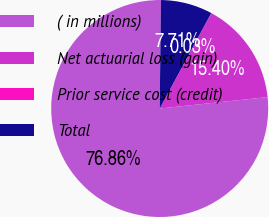Convert chart. <chart><loc_0><loc_0><loc_500><loc_500><pie_chart><fcel>( in millions)<fcel>Net actuarial loss (gain)<fcel>Prior service cost (credit)<fcel>Total<nl><fcel>76.86%<fcel>15.4%<fcel>0.03%<fcel>7.71%<nl></chart> 